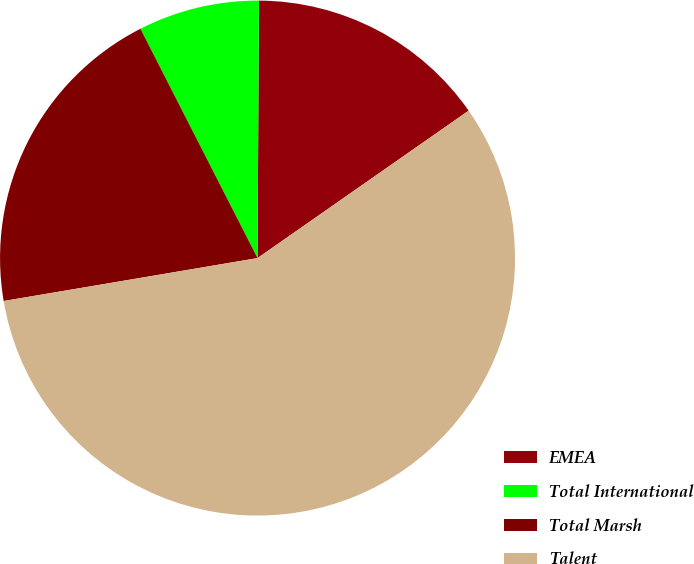Convert chart. <chart><loc_0><loc_0><loc_500><loc_500><pie_chart><fcel>EMEA<fcel>Total International<fcel>Total Marsh<fcel>Talent<nl><fcel>15.21%<fcel>7.6%<fcel>20.15%<fcel>57.03%<nl></chart> 